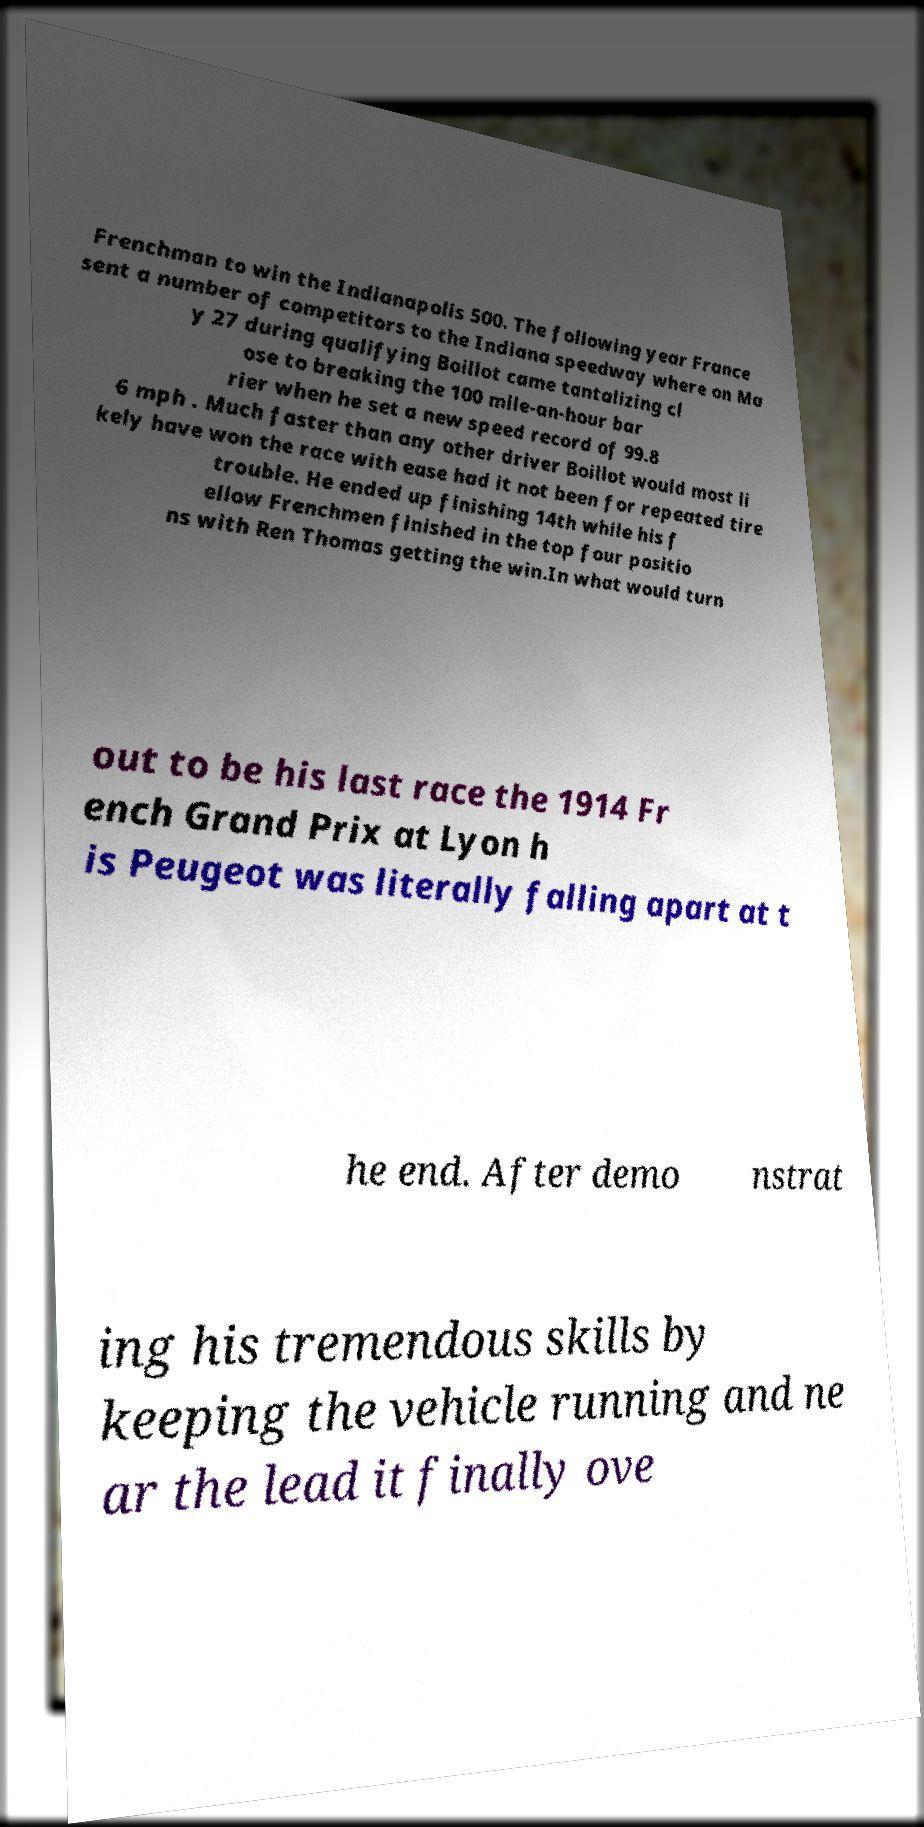For documentation purposes, I need the text within this image transcribed. Could you provide that? Frenchman to win the Indianapolis 500. The following year France sent a number of competitors to the Indiana speedway where on Ma y 27 during qualifying Boillot came tantalizing cl ose to breaking the 100 mile-an-hour bar rier when he set a new speed record of 99.8 6 mph . Much faster than any other driver Boillot would most li kely have won the race with ease had it not been for repeated tire trouble. He ended up finishing 14th while his f ellow Frenchmen finished in the top four positio ns with Ren Thomas getting the win.In what would turn out to be his last race the 1914 Fr ench Grand Prix at Lyon h is Peugeot was literally falling apart at t he end. After demo nstrat ing his tremendous skills by keeping the vehicle running and ne ar the lead it finally ove 